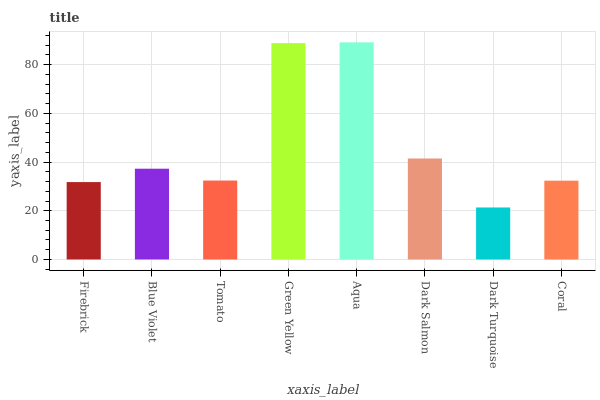Is Dark Turquoise the minimum?
Answer yes or no. Yes. Is Aqua the maximum?
Answer yes or no. Yes. Is Blue Violet the minimum?
Answer yes or no. No. Is Blue Violet the maximum?
Answer yes or no. No. Is Blue Violet greater than Firebrick?
Answer yes or no. Yes. Is Firebrick less than Blue Violet?
Answer yes or no. Yes. Is Firebrick greater than Blue Violet?
Answer yes or no. No. Is Blue Violet less than Firebrick?
Answer yes or no. No. Is Blue Violet the high median?
Answer yes or no. Yes. Is Tomato the low median?
Answer yes or no. Yes. Is Aqua the high median?
Answer yes or no. No. Is Blue Violet the low median?
Answer yes or no. No. 